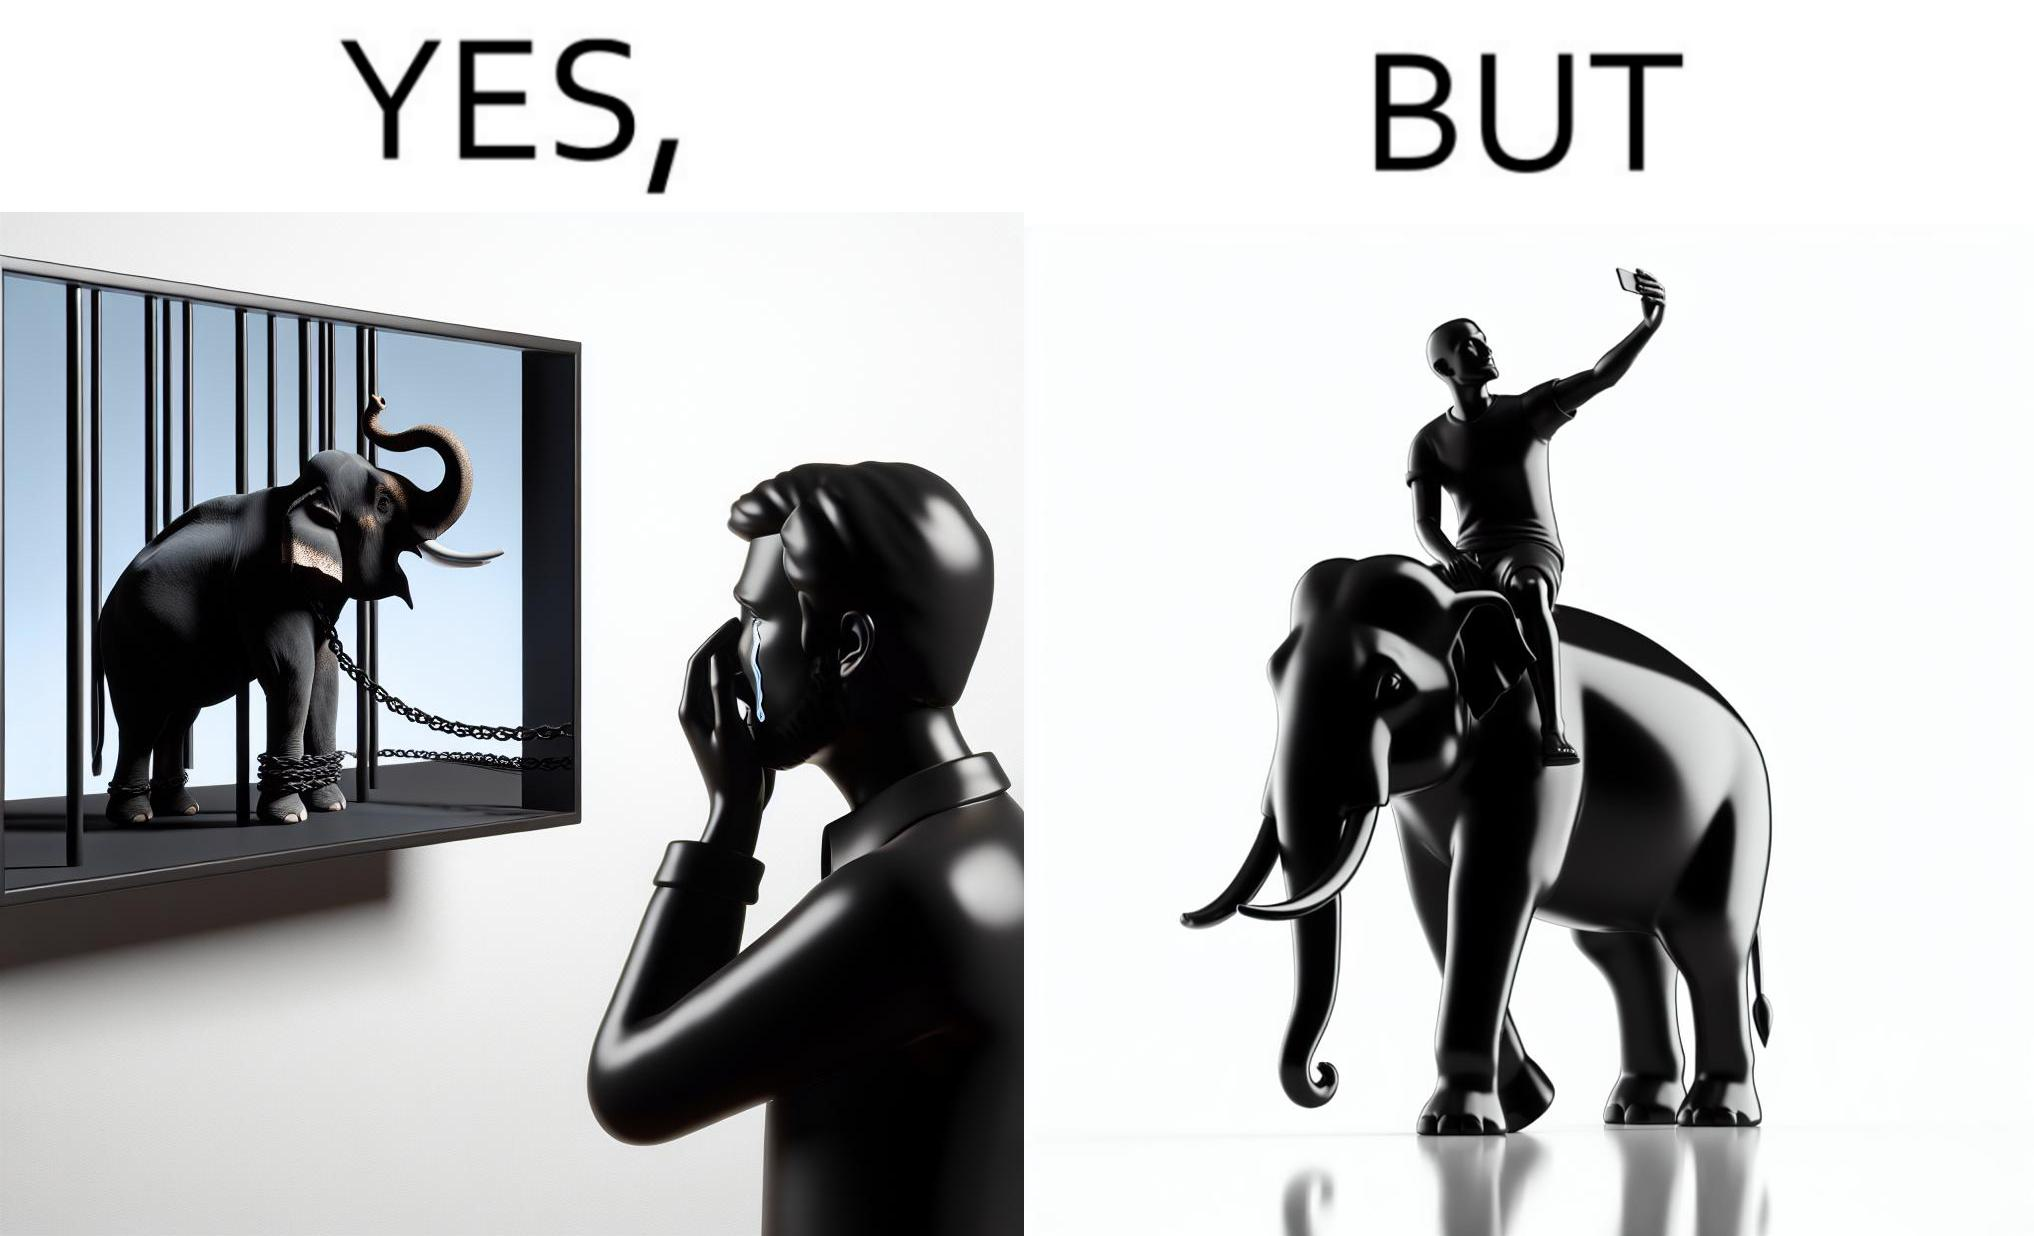Is this a satirical image? Yes, this image is satirical. 